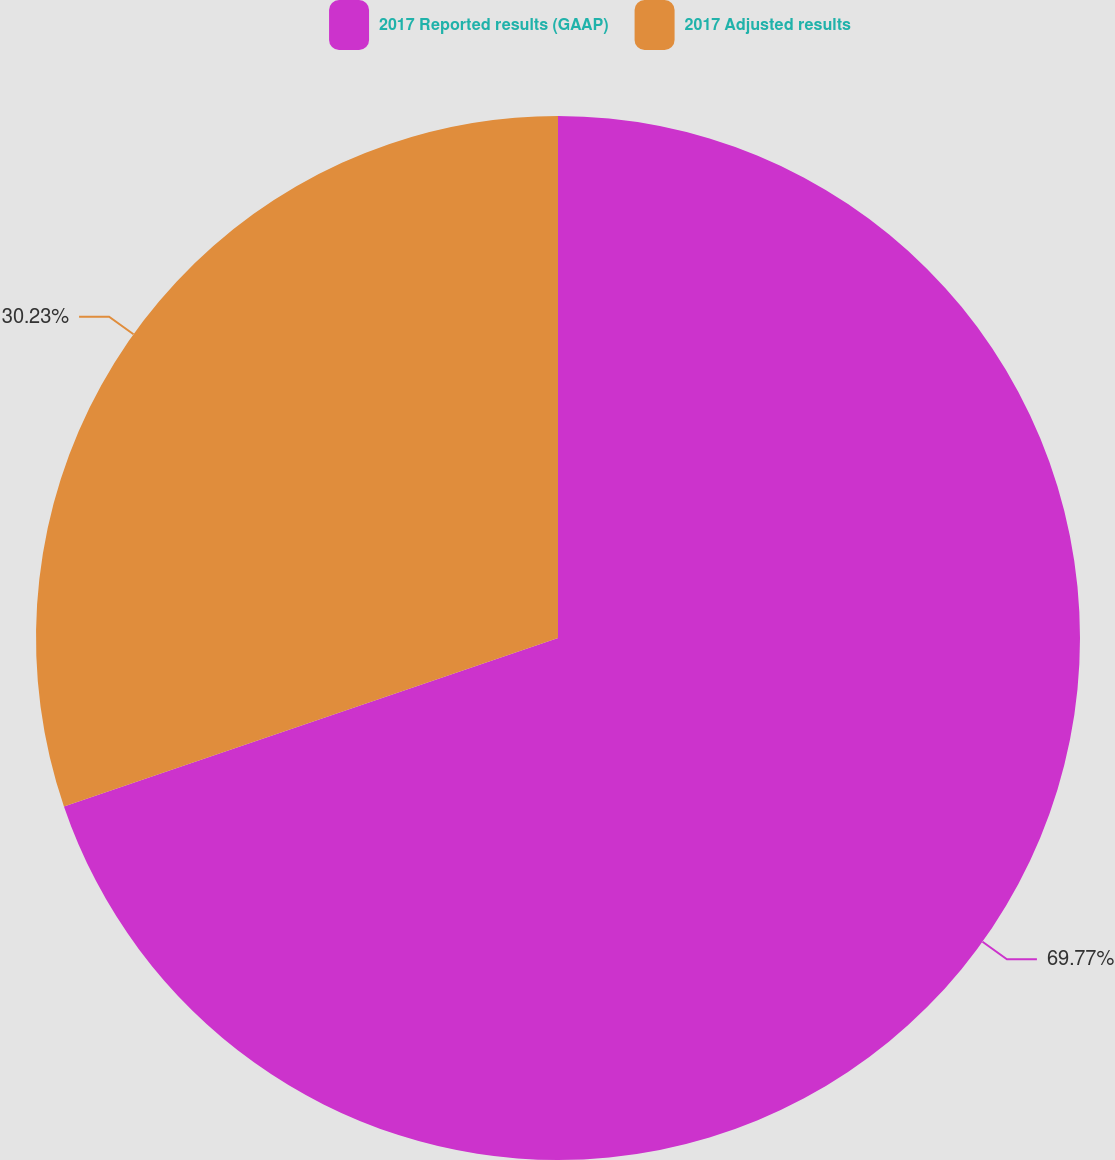<chart> <loc_0><loc_0><loc_500><loc_500><pie_chart><fcel>2017 Reported results (GAAP)<fcel>2017 Adjusted results<nl><fcel>69.77%<fcel>30.23%<nl></chart> 